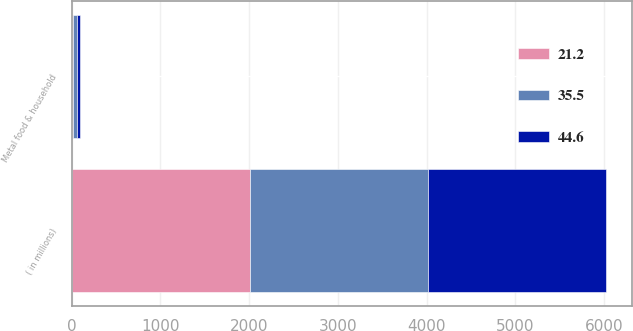<chart> <loc_0><loc_0><loc_500><loc_500><stacked_bar_chart><ecel><fcel>( in millions)<fcel>Metal food & household<nl><fcel>35.5<fcel>2007<fcel>44.2<nl><fcel>44.6<fcel>2006<fcel>35.5<nl><fcel>21.2<fcel>2005<fcel>11.2<nl></chart> 